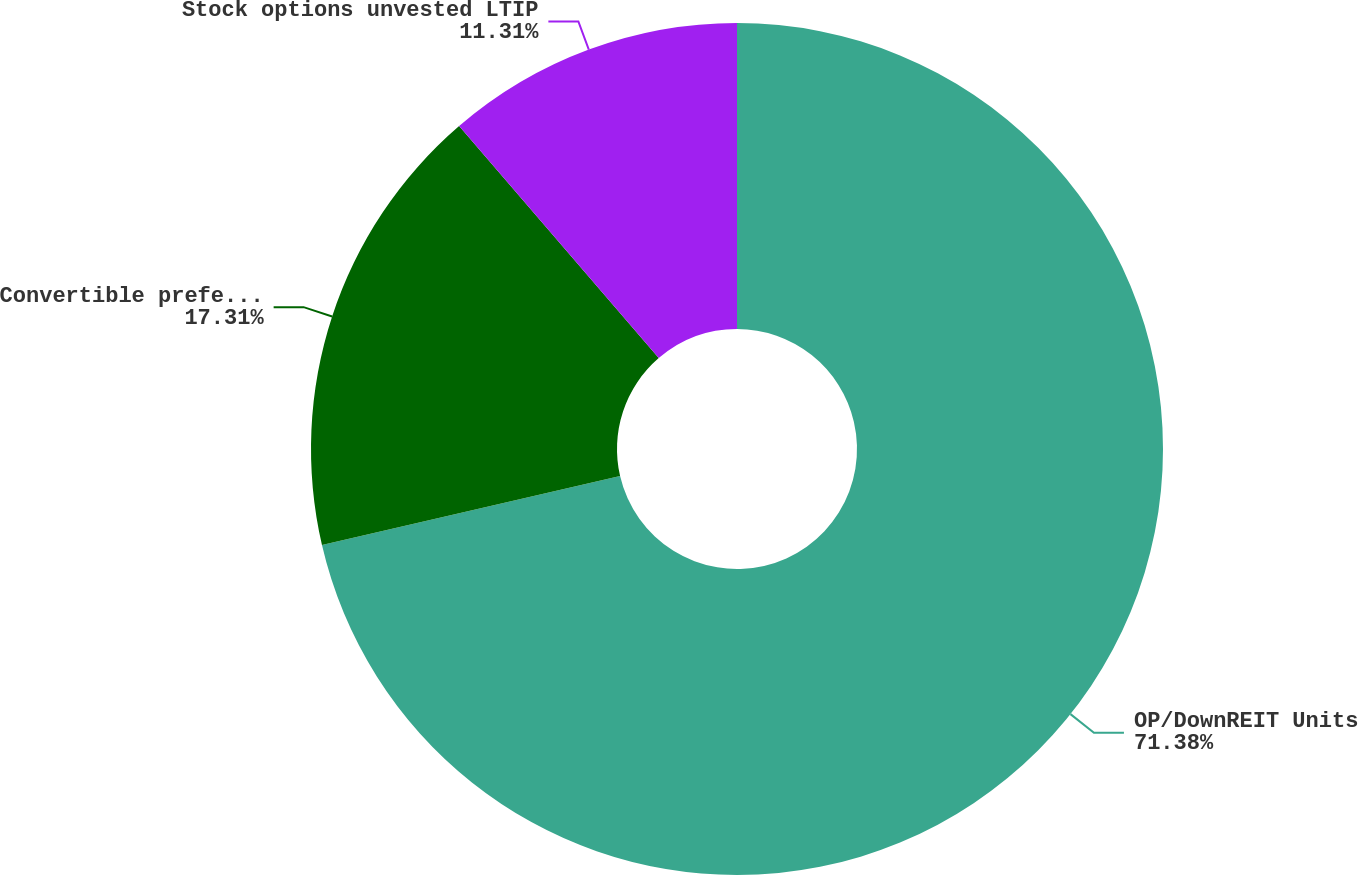Convert chart. <chart><loc_0><loc_0><loc_500><loc_500><pie_chart><fcel>OP/DownREIT Units<fcel>Convertible preferred stock<fcel>Stock options unvested LTIP<nl><fcel>71.38%<fcel>17.31%<fcel>11.31%<nl></chart> 